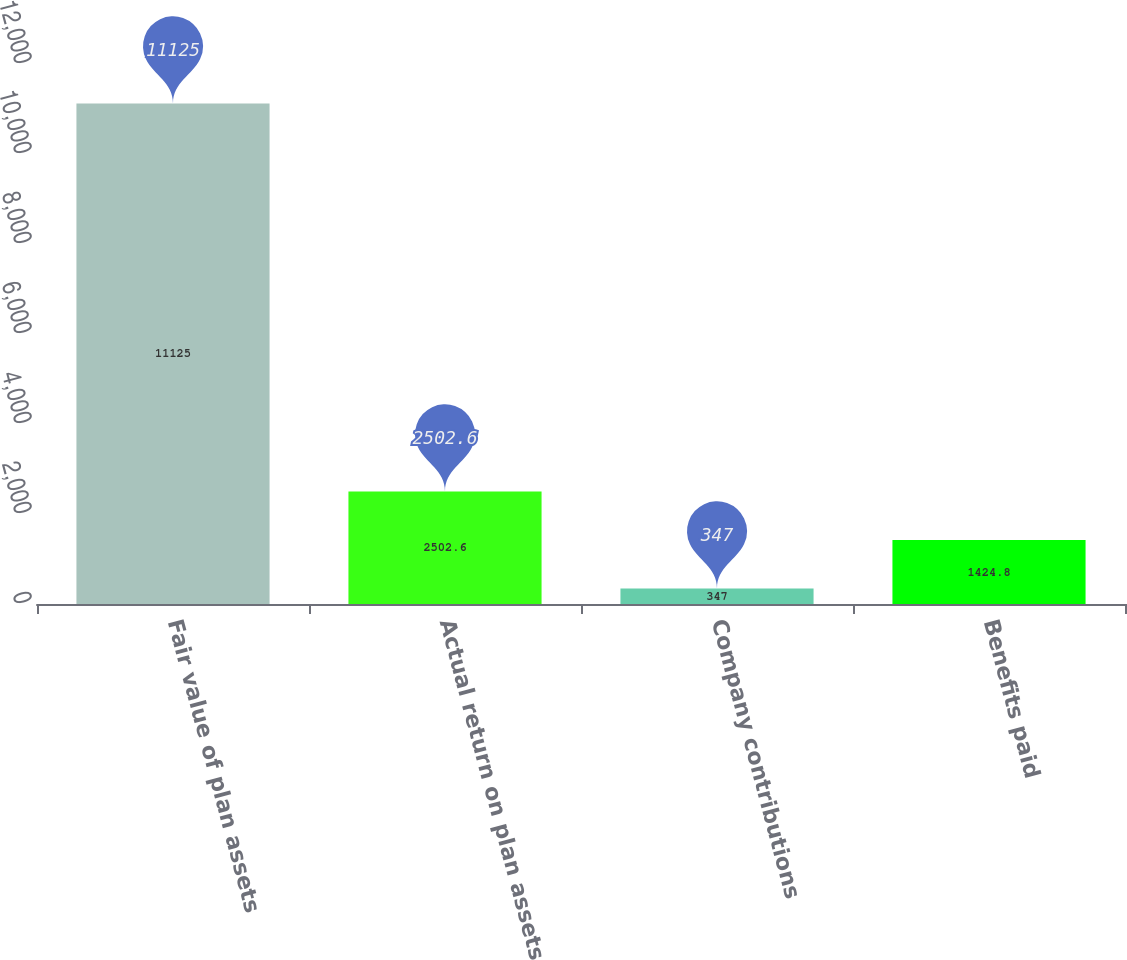<chart> <loc_0><loc_0><loc_500><loc_500><bar_chart><fcel>Fair value of plan assets<fcel>Actual return on plan assets<fcel>Company contributions<fcel>Benefits paid<nl><fcel>11125<fcel>2502.6<fcel>347<fcel>1424.8<nl></chart> 